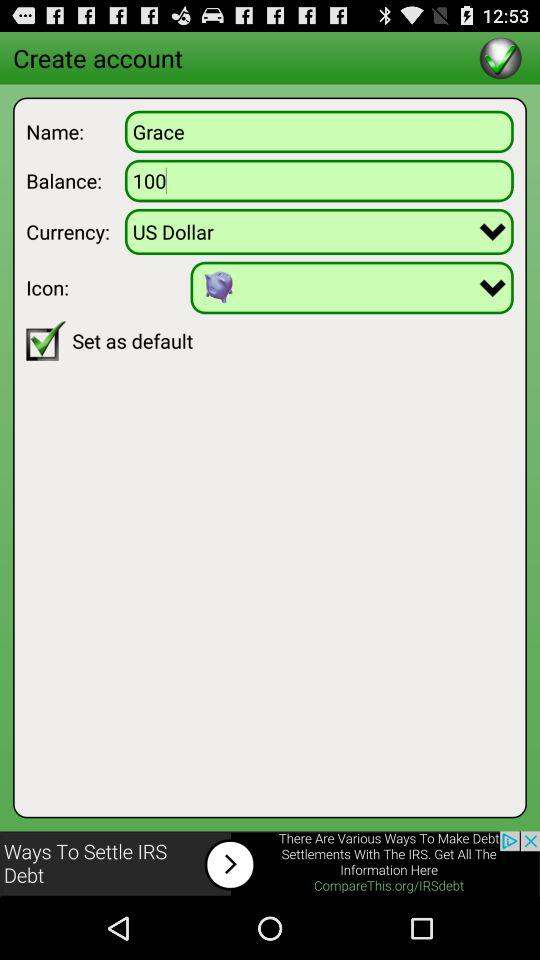What is the status of the "Set as default"? The status is on. 